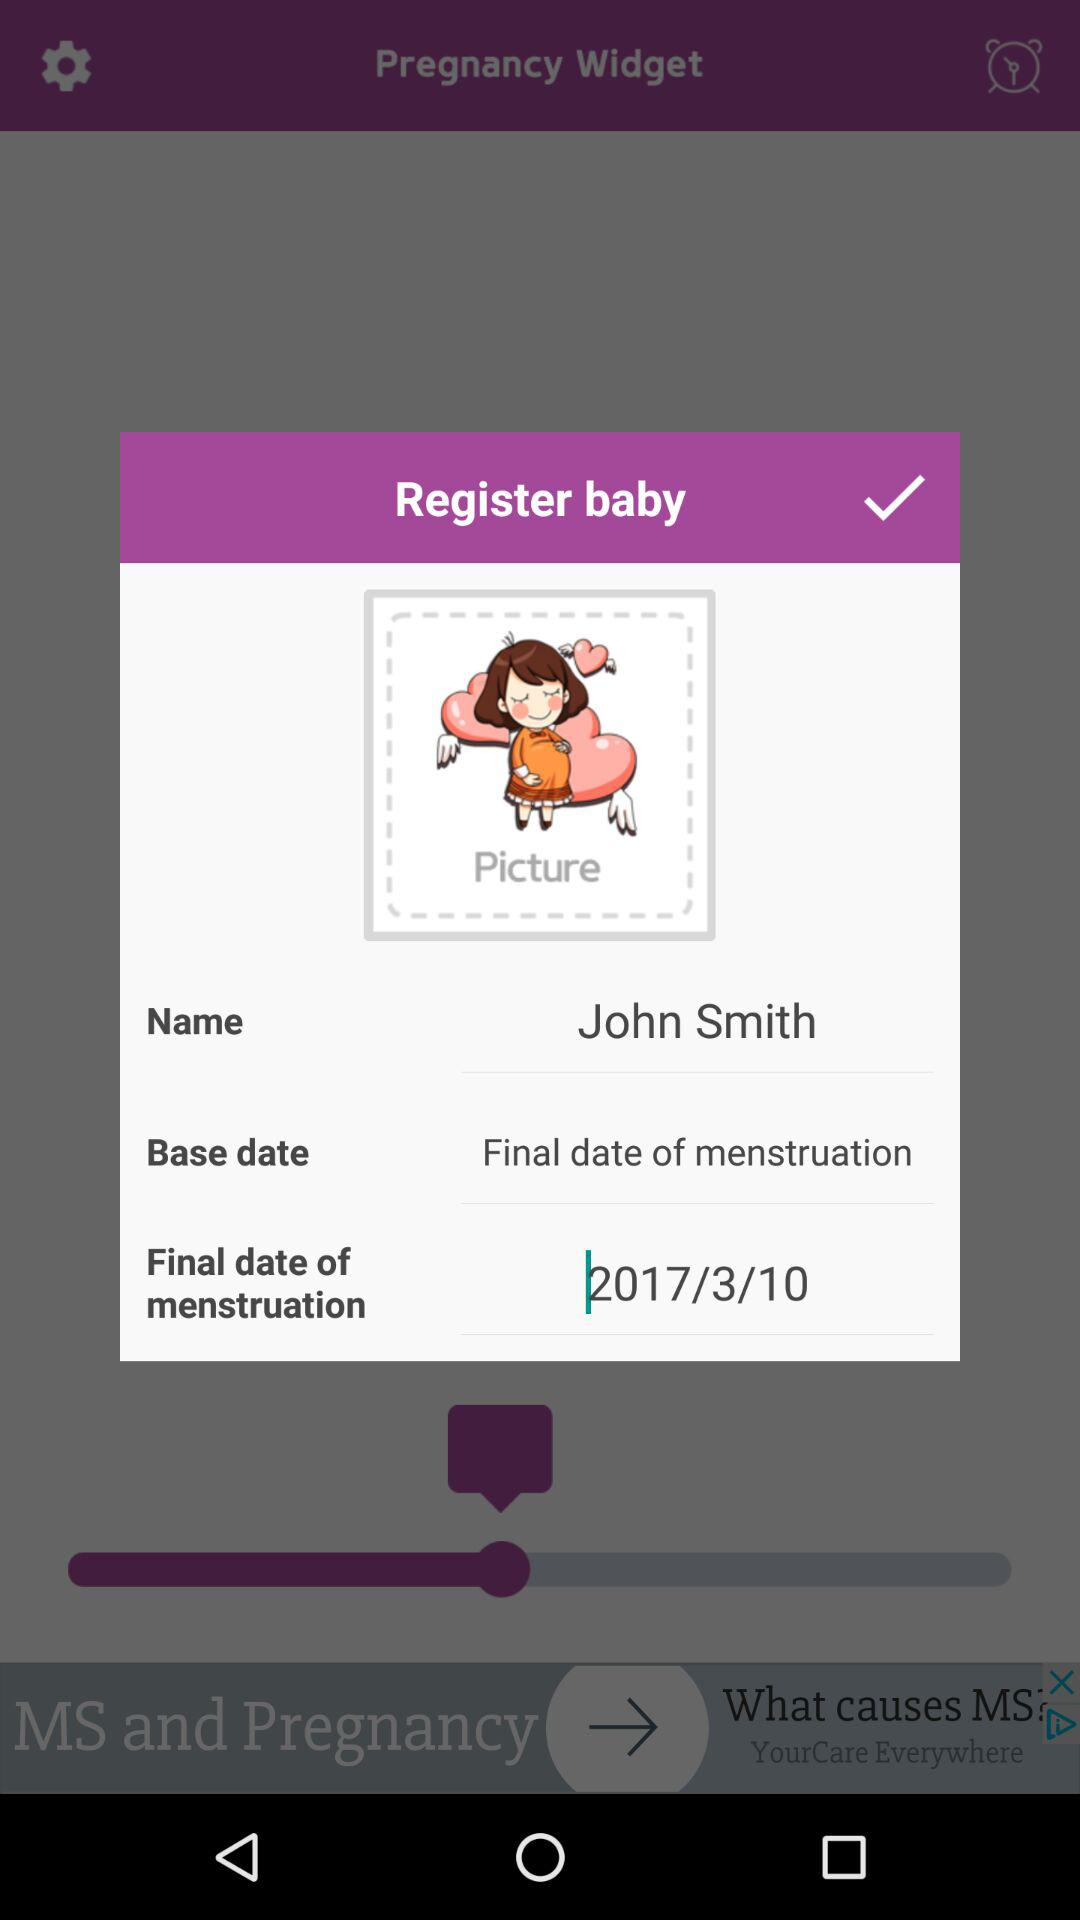What is the name of the person? The name of the person is John Smith. 